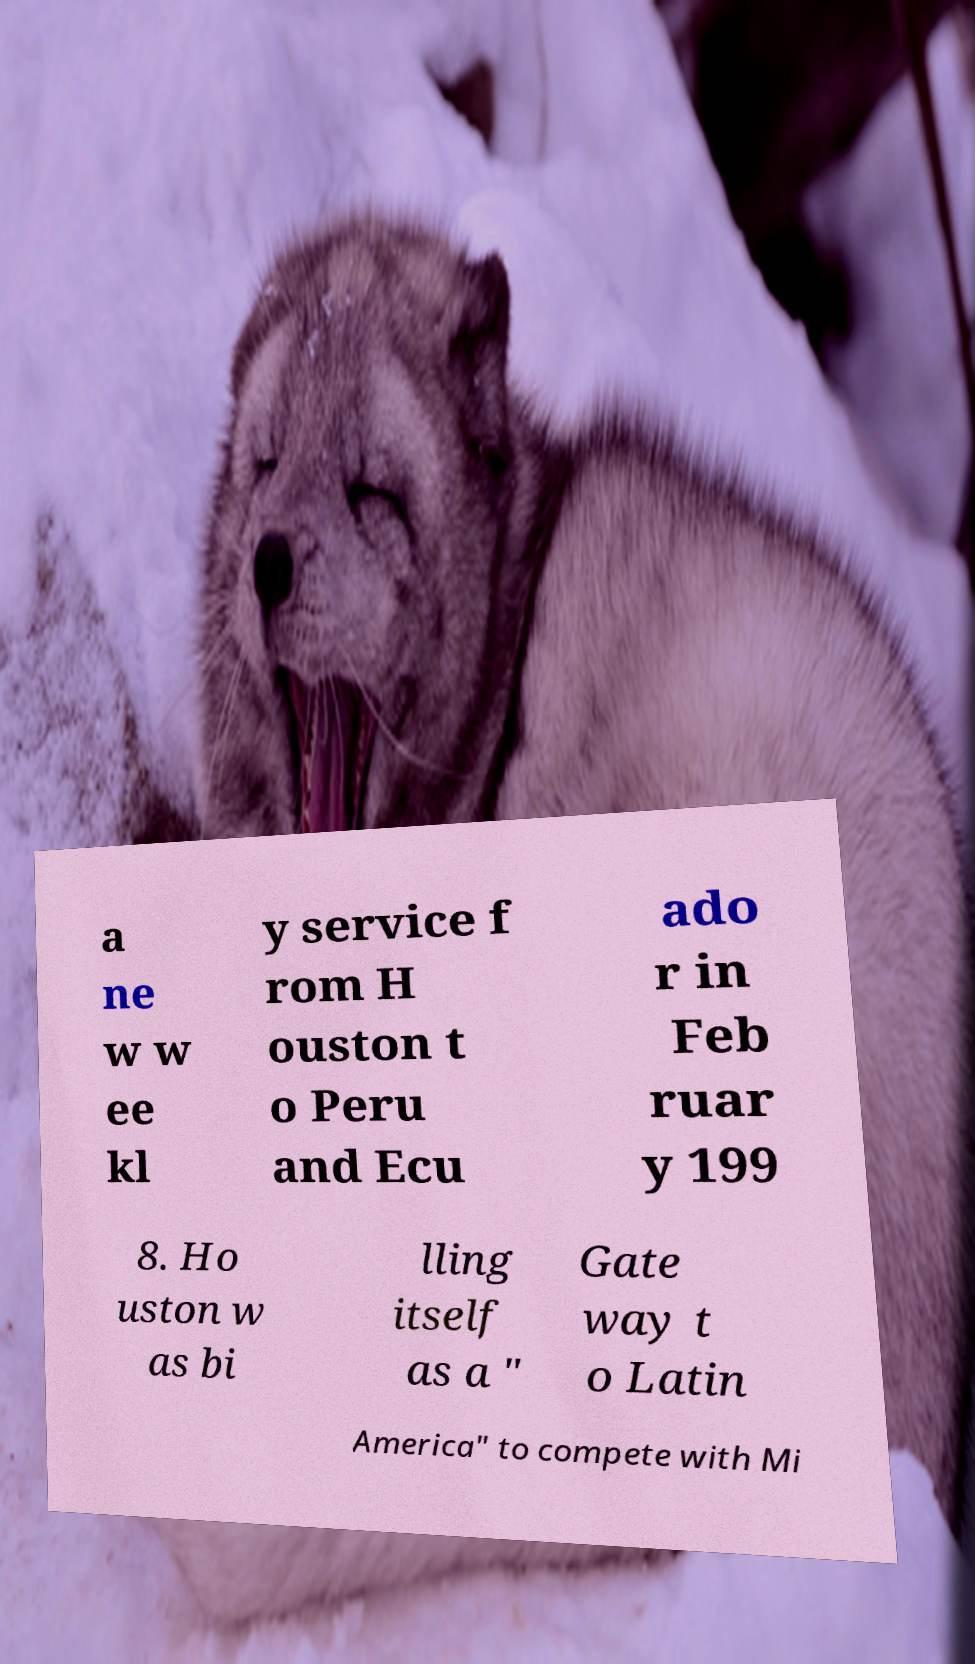I need the written content from this picture converted into text. Can you do that? a ne w w ee kl y service f rom H ouston t o Peru and Ecu ado r in Feb ruar y 199 8. Ho uston w as bi lling itself as a " Gate way t o Latin America" to compete with Mi 